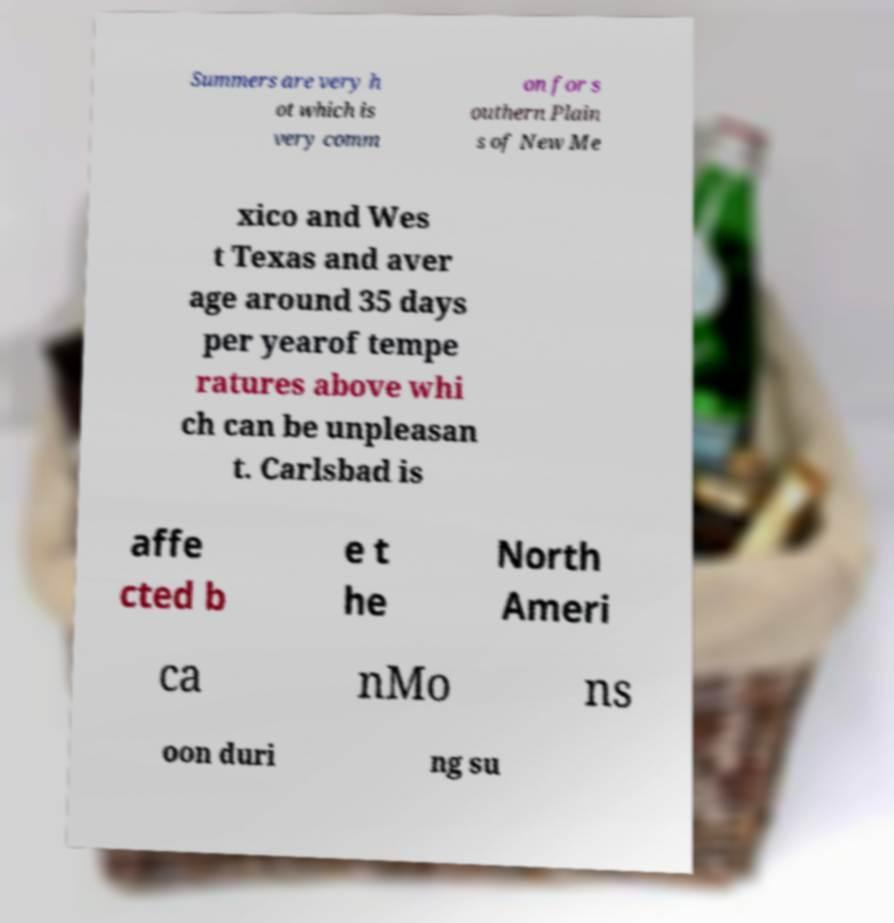Can you read and provide the text displayed in the image?This photo seems to have some interesting text. Can you extract and type it out for me? Summers are very h ot which is very comm on for s outhern Plain s of New Me xico and Wes t Texas and aver age around 35 days per yearof tempe ratures above whi ch can be unpleasan t. Carlsbad is affe cted b e t he North Ameri ca nMo ns oon duri ng su 